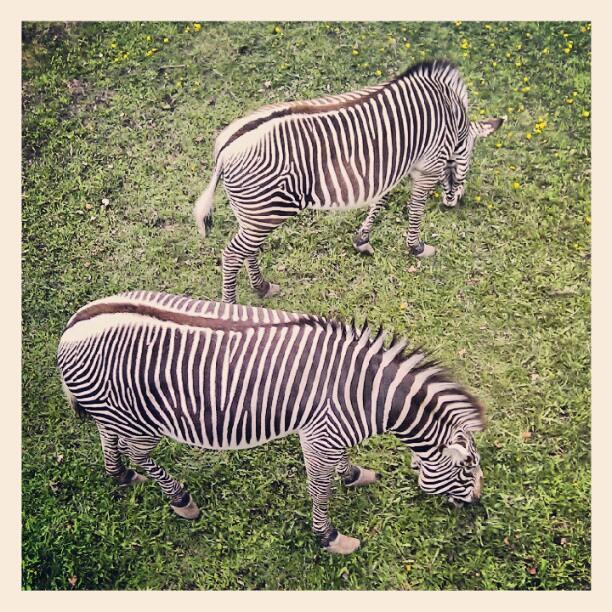Are these animals carnivorous?
Quick response, please. No. What are the animals doing?
Keep it brief. Eating. Is the zebra feasting on grass?
Be succinct. Yes. 